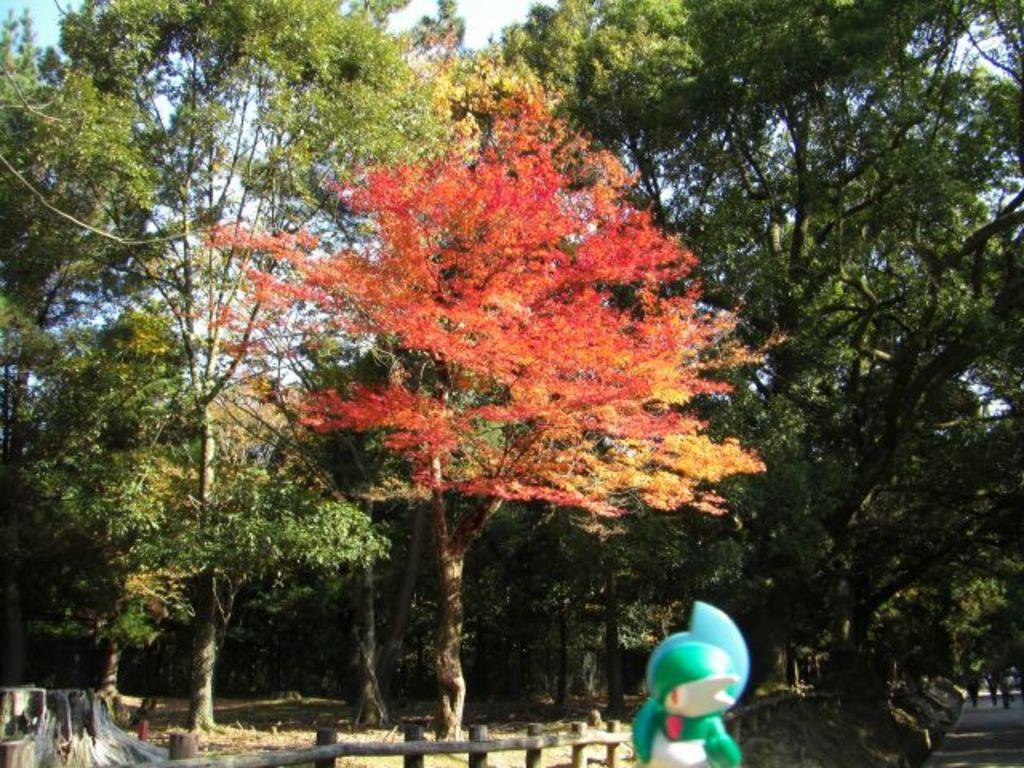How would you summarize this image in a sentence or two? There is one object at the bottom of this image, and there are some trees in the middle of this image, and there is a sky in the background. 